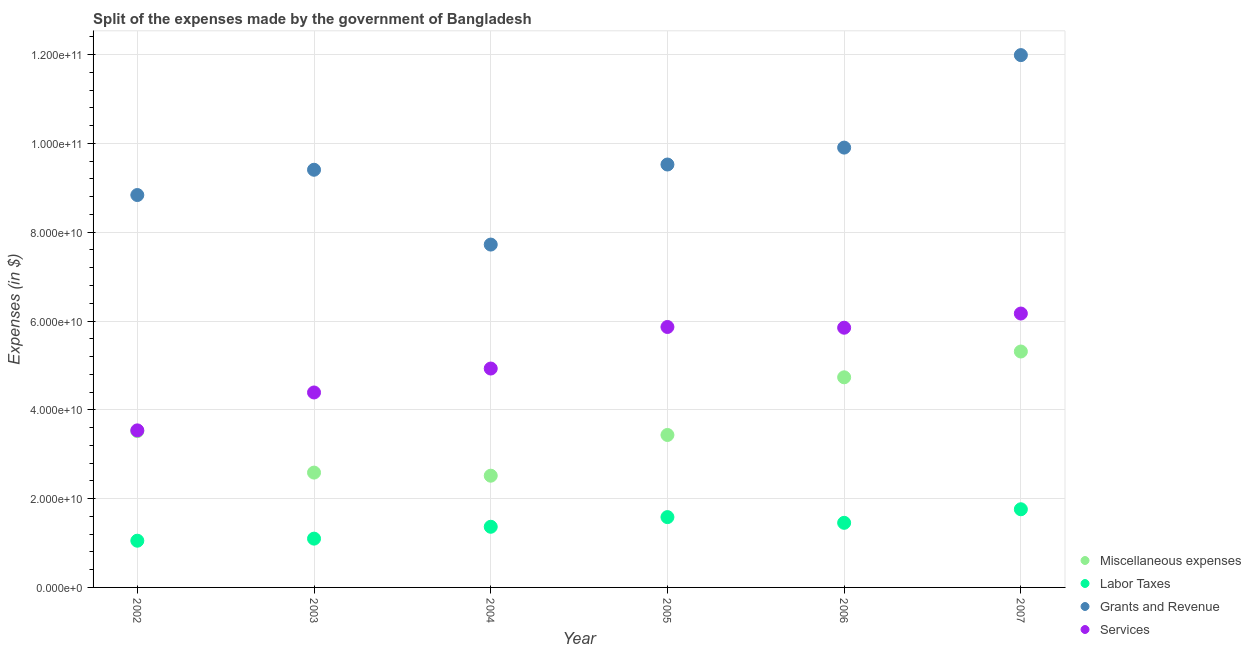Is the number of dotlines equal to the number of legend labels?
Make the answer very short. Yes. What is the amount spent on services in 2004?
Make the answer very short. 4.93e+1. Across all years, what is the maximum amount spent on services?
Your response must be concise. 6.17e+1. Across all years, what is the minimum amount spent on labor taxes?
Offer a terse response. 1.05e+1. What is the total amount spent on grants and revenue in the graph?
Keep it short and to the point. 5.74e+11. What is the difference between the amount spent on miscellaneous expenses in 2003 and that in 2004?
Offer a very short reply. 6.99e+08. What is the difference between the amount spent on labor taxes in 2007 and the amount spent on grants and revenue in 2004?
Provide a short and direct response. -5.96e+1. What is the average amount spent on grants and revenue per year?
Your answer should be compact. 9.56e+1. In the year 2003, what is the difference between the amount spent on labor taxes and amount spent on services?
Make the answer very short. -3.29e+1. In how many years, is the amount spent on grants and revenue greater than 4000000000 $?
Provide a short and direct response. 6. What is the ratio of the amount spent on miscellaneous expenses in 2003 to that in 2007?
Offer a terse response. 0.49. What is the difference between the highest and the second highest amount spent on labor taxes?
Your response must be concise. 1.77e+09. What is the difference between the highest and the lowest amount spent on miscellaneous expenses?
Your answer should be compact. 2.80e+1. In how many years, is the amount spent on labor taxes greater than the average amount spent on labor taxes taken over all years?
Make the answer very short. 3. Is the sum of the amount spent on miscellaneous expenses in 2003 and 2005 greater than the maximum amount spent on grants and revenue across all years?
Ensure brevity in your answer.  No. Is it the case that in every year, the sum of the amount spent on miscellaneous expenses and amount spent on labor taxes is greater than the amount spent on grants and revenue?
Offer a very short reply. No. Is the amount spent on services strictly greater than the amount spent on miscellaneous expenses over the years?
Give a very brief answer. Yes. Is the amount spent on miscellaneous expenses strictly less than the amount spent on services over the years?
Your answer should be compact. Yes. Are the values on the major ticks of Y-axis written in scientific E-notation?
Keep it short and to the point. Yes. Does the graph contain any zero values?
Offer a very short reply. No. How many legend labels are there?
Give a very brief answer. 4. How are the legend labels stacked?
Your answer should be compact. Vertical. What is the title of the graph?
Provide a succinct answer. Split of the expenses made by the government of Bangladesh. Does "United Kingdom" appear as one of the legend labels in the graph?
Offer a terse response. No. What is the label or title of the Y-axis?
Your answer should be very brief. Expenses (in $). What is the Expenses (in $) of Miscellaneous expenses in 2002?
Your response must be concise. 3.52e+1. What is the Expenses (in $) in Labor Taxes in 2002?
Your response must be concise. 1.05e+1. What is the Expenses (in $) of Grants and Revenue in 2002?
Give a very brief answer. 8.84e+1. What is the Expenses (in $) in Services in 2002?
Your answer should be very brief. 3.54e+1. What is the Expenses (in $) of Miscellaneous expenses in 2003?
Your answer should be compact. 2.59e+1. What is the Expenses (in $) of Labor Taxes in 2003?
Make the answer very short. 1.10e+1. What is the Expenses (in $) of Grants and Revenue in 2003?
Offer a very short reply. 9.41e+1. What is the Expenses (in $) in Services in 2003?
Provide a succinct answer. 4.39e+1. What is the Expenses (in $) of Miscellaneous expenses in 2004?
Your answer should be very brief. 2.52e+1. What is the Expenses (in $) of Labor Taxes in 2004?
Provide a succinct answer. 1.37e+1. What is the Expenses (in $) of Grants and Revenue in 2004?
Your answer should be compact. 7.72e+1. What is the Expenses (in $) of Services in 2004?
Your answer should be very brief. 4.93e+1. What is the Expenses (in $) of Miscellaneous expenses in 2005?
Your answer should be very brief. 3.43e+1. What is the Expenses (in $) of Labor Taxes in 2005?
Offer a very short reply. 1.58e+1. What is the Expenses (in $) in Grants and Revenue in 2005?
Your answer should be very brief. 9.52e+1. What is the Expenses (in $) of Services in 2005?
Your response must be concise. 5.87e+1. What is the Expenses (in $) of Miscellaneous expenses in 2006?
Keep it short and to the point. 4.73e+1. What is the Expenses (in $) in Labor Taxes in 2006?
Ensure brevity in your answer.  1.45e+1. What is the Expenses (in $) in Grants and Revenue in 2006?
Make the answer very short. 9.91e+1. What is the Expenses (in $) of Services in 2006?
Give a very brief answer. 5.85e+1. What is the Expenses (in $) in Miscellaneous expenses in 2007?
Your response must be concise. 5.31e+1. What is the Expenses (in $) in Labor Taxes in 2007?
Keep it short and to the point. 1.76e+1. What is the Expenses (in $) in Grants and Revenue in 2007?
Offer a terse response. 1.20e+11. What is the Expenses (in $) of Services in 2007?
Make the answer very short. 6.17e+1. Across all years, what is the maximum Expenses (in $) in Miscellaneous expenses?
Your answer should be very brief. 5.31e+1. Across all years, what is the maximum Expenses (in $) in Labor Taxes?
Ensure brevity in your answer.  1.76e+1. Across all years, what is the maximum Expenses (in $) of Grants and Revenue?
Keep it short and to the point. 1.20e+11. Across all years, what is the maximum Expenses (in $) of Services?
Your answer should be very brief. 6.17e+1. Across all years, what is the minimum Expenses (in $) of Miscellaneous expenses?
Provide a short and direct response. 2.52e+1. Across all years, what is the minimum Expenses (in $) of Labor Taxes?
Offer a terse response. 1.05e+1. Across all years, what is the minimum Expenses (in $) in Grants and Revenue?
Keep it short and to the point. 7.72e+1. Across all years, what is the minimum Expenses (in $) of Services?
Keep it short and to the point. 3.54e+1. What is the total Expenses (in $) in Miscellaneous expenses in the graph?
Offer a terse response. 2.21e+11. What is the total Expenses (in $) of Labor Taxes in the graph?
Provide a short and direct response. 8.32e+1. What is the total Expenses (in $) of Grants and Revenue in the graph?
Provide a short and direct response. 5.74e+11. What is the total Expenses (in $) of Services in the graph?
Give a very brief answer. 3.07e+11. What is the difference between the Expenses (in $) in Miscellaneous expenses in 2002 and that in 2003?
Your answer should be compact. 9.34e+09. What is the difference between the Expenses (in $) in Labor Taxes in 2002 and that in 2003?
Your answer should be very brief. -4.67e+08. What is the difference between the Expenses (in $) in Grants and Revenue in 2002 and that in 2003?
Your answer should be compact. -5.69e+09. What is the difference between the Expenses (in $) in Services in 2002 and that in 2003?
Ensure brevity in your answer.  -8.54e+09. What is the difference between the Expenses (in $) in Miscellaneous expenses in 2002 and that in 2004?
Your answer should be very brief. 1.00e+1. What is the difference between the Expenses (in $) in Labor Taxes in 2002 and that in 2004?
Ensure brevity in your answer.  -3.14e+09. What is the difference between the Expenses (in $) in Grants and Revenue in 2002 and that in 2004?
Provide a short and direct response. 1.12e+1. What is the difference between the Expenses (in $) in Services in 2002 and that in 2004?
Your response must be concise. -1.39e+1. What is the difference between the Expenses (in $) in Miscellaneous expenses in 2002 and that in 2005?
Offer a very short reply. 8.64e+08. What is the difference between the Expenses (in $) in Labor Taxes in 2002 and that in 2005?
Offer a very short reply. -5.32e+09. What is the difference between the Expenses (in $) in Grants and Revenue in 2002 and that in 2005?
Make the answer very short. -6.87e+09. What is the difference between the Expenses (in $) in Services in 2002 and that in 2005?
Ensure brevity in your answer.  -2.33e+1. What is the difference between the Expenses (in $) of Miscellaneous expenses in 2002 and that in 2006?
Your response must be concise. -1.21e+1. What is the difference between the Expenses (in $) of Labor Taxes in 2002 and that in 2006?
Provide a short and direct response. -4.03e+09. What is the difference between the Expenses (in $) of Grants and Revenue in 2002 and that in 2006?
Your answer should be very brief. -1.07e+1. What is the difference between the Expenses (in $) of Services in 2002 and that in 2006?
Keep it short and to the point. -2.31e+1. What is the difference between the Expenses (in $) of Miscellaneous expenses in 2002 and that in 2007?
Your answer should be very brief. -1.79e+1. What is the difference between the Expenses (in $) in Labor Taxes in 2002 and that in 2007?
Your response must be concise. -7.08e+09. What is the difference between the Expenses (in $) of Grants and Revenue in 2002 and that in 2007?
Your answer should be very brief. -3.15e+1. What is the difference between the Expenses (in $) of Services in 2002 and that in 2007?
Make the answer very short. -2.63e+1. What is the difference between the Expenses (in $) in Miscellaneous expenses in 2003 and that in 2004?
Offer a very short reply. 6.99e+08. What is the difference between the Expenses (in $) of Labor Taxes in 2003 and that in 2004?
Your response must be concise. -2.67e+09. What is the difference between the Expenses (in $) of Grants and Revenue in 2003 and that in 2004?
Your answer should be compact. 1.69e+1. What is the difference between the Expenses (in $) in Services in 2003 and that in 2004?
Provide a short and direct response. -5.39e+09. What is the difference between the Expenses (in $) in Miscellaneous expenses in 2003 and that in 2005?
Keep it short and to the point. -8.47e+09. What is the difference between the Expenses (in $) in Labor Taxes in 2003 and that in 2005?
Your answer should be compact. -4.85e+09. What is the difference between the Expenses (in $) in Grants and Revenue in 2003 and that in 2005?
Offer a very short reply. -1.18e+09. What is the difference between the Expenses (in $) of Services in 2003 and that in 2005?
Provide a succinct answer. -1.48e+1. What is the difference between the Expenses (in $) of Miscellaneous expenses in 2003 and that in 2006?
Make the answer very short. -2.15e+1. What is the difference between the Expenses (in $) in Labor Taxes in 2003 and that in 2006?
Keep it short and to the point. -3.56e+09. What is the difference between the Expenses (in $) of Grants and Revenue in 2003 and that in 2006?
Ensure brevity in your answer.  -4.99e+09. What is the difference between the Expenses (in $) in Services in 2003 and that in 2006?
Your answer should be compact. -1.46e+1. What is the difference between the Expenses (in $) of Miscellaneous expenses in 2003 and that in 2007?
Keep it short and to the point. -2.73e+1. What is the difference between the Expenses (in $) of Labor Taxes in 2003 and that in 2007?
Keep it short and to the point. -6.61e+09. What is the difference between the Expenses (in $) in Grants and Revenue in 2003 and that in 2007?
Ensure brevity in your answer.  -2.58e+1. What is the difference between the Expenses (in $) in Services in 2003 and that in 2007?
Your response must be concise. -1.78e+1. What is the difference between the Expenses (in $) of Miscellaneous expenses in 2004 and that in 2005?
Give a very brief answer. -9.17e+09. What is the difference between the Expenses (in $) of Labor Taxes in 2004 and that in 2005?
Ensure brevity in your answer.  -2.18e+09. What is the difference between the Expenses (in $) of Grants and Revenue in 2004 and that in 2005?
Make the answer very short. -1.80e+1. What is the difference between the Expenses (in $) in Services in 2004 and that in 2005?
Give a very brief answer. -9.36e+09. What is the difference between the Expenses (in $) in Miscellaneous expenses in 2004 and that in 2006?
Provide a short and direct response. -2.22e+1. What is the difference between the Expenses (in $) in Labor Taxes in 2004 and that in 2006?
Give a very brief answer. -8.88e+08. What is the difference between the Expenses (in $) in Grants and Revenue in 2004 and that in 2006?
Your response must be concise. -2.18e+1. What is the difference between the Expenses (in $) in Services in 2004 and that in 2006?
Provide a succinct answer. -9.19e+09. What is the difference between the Expenses (in $) of Miscellaneous expenses in 2004 and that in 2007?
Your answer should be compact. -2.80e+1. What is the difference between the Expenses (in $) in Labor Taxes in 2004 and that in 2007?
Offer a terse response. -3.94e+09. What is the difference between the Expenses (in $) of Grants and Revenue in 2004 and that in 2007?
Provide a succinct answer. -4.27e+1. What is the difference between the Expenses (in $) in Services in 2004 and that in 2007?
Provide a succinct answer. -1.24e+1. What is the difference between the Expenses (in $) of Miscellaneous expenses in 2005 and that in 2006?
Offer a very short reply. -1.30e+1. What is the difference between the Expenses (in $) in Labor Taxes in 2005 and that in 2006?
Keep it short and to the point. 1.29e+09. What is the difference between the Expenses (in $) in Grants and Revenue in 2005 and that in 2006?
Your answer should be very brief. -3.81e+09. What is the difference between the Expenses (in $) in Services in 2005 and that in 2006?
Your answer should be very brief. 1.67e+08. What is the difference between the Expenses (in $) of Miscellaneous expenses in 2005 and that in 2007?
Offer a terse response. -1.88e+1. What is the difference between the Expenses (in $) of Labor Taxes in 2005 and that in 2007?
Ensure brevity in your answer.  -1.77e+09. What is the difference between the Expenses (in $) of Grants and Revenue in 2005 and that in 2007?
Your response must be concise. -2.46e+1. What is the difference between the Expenses (in $) of Services in 2005 and that in 2007?
Ensure brevity in your answer.  -3.03e+09. What is the difference between the Expenses (in $) of Miscellaneous expenses in 2006 and that in 2007?
Give a very brief answer. -5.81e+09. What is the difference between the Expenses (in $) in Labor Taxes in 2006 and that in 2007?
Your answer should be very brief. -3.05e+09. What is the difference between the Expenses (in $) of Grants and Revenue in 2006 and that in 2007?
Ensure brevity in your answer.  -2.08e+1. What is the difference between the Expenses (in $) in Services in 2006 and that in 2007?
Offer a terse response. -3.20e+09. What is the difference between the Expenses (in $) of Miscellaneous expenses in 2002 and the Expenses (in $) of Labor Taxes in 2003?
Give a very brief answer. 2.42e+1. What is the difference between the Expenses (in $) in Miscellaneous expenses in 2002 and the Expenses (in $) in Grants and Revenue in 2003?
Your answer should be compact. -5.89e+1. What is the difference between the Expenses (in $) in Miscellaneous expenses in 2002 and the Expenses (in $) in Services in 2003?
Your response must be concise. -8.71e+09. What is the difference between the Expenses (in $) in Labor Taxes in 2002 and the Expenses (in $) in Grants and Revenue in 2003?
Offer a terse response. -8.35e+1. What is the difference between the Expenses (in $) of Labor Taxes in 2002 and the Expenses (in $) of Services in 2003?
Offer a very short reply. -3.34e+1. What is the difference between the Expenses (in $) of Grants and Revenue in 2002 and the Expenses (in $) of Services in 2003?
Offer a very short reply. 4.45e+1. What is the difference between the Expenses (in $) in Miscellaneous expenses in 2002 and the Expenses (in $) in Labor Taxes in 2004?
Your answer should be very brief. 2.15e+1. What is the difference between the Expenses (in $) of Miscellaneous expenses in 2002 and the Expenses (in $) of Grants and Revenue in 2004?
Provide a short and direct response. -4.20e+1. What is the difference between the Expenses (in $) of Miscellaneous expenses in 2002 and the Expenses (in $) of Services in 2004?
Keep it short and to the point. -1.41e+1. What is the difference between the Expenses (in $) of Labor Taxes in 2002 and the Expenses (in $) of Grants and Revenue in 2004?
Your answer should be compact. -6.67e+1. What is the difference between the Expenses (in $) of Labor Taxes in 2002 and the Expenses (in $) of Services in 2004?
Your answer should be compact. -3.88e+1. What is the difference between the Expenses (in $) of Grants and Revenue in 2002 and the Expenses (in $) of Services in 2004?
Ensure brevity in your answer.  3.91e+1. What is the difference between the Expenses (in $) in Miscellaneous expenses in 2002 and the Expenses (in $) in Labor Taxes in 2005?
Ensure brevity in your answer.  1.94e+1. What is the difference between the Expenses (in $) of Miscellaneous expenses in 2002 and the Expenses (in $) of Grants and Revenue in 2005?
Provide a succinct answer. -6.00e+1. What is the difference between the Expenses (in $) in Miscellaneous expenses in 2002 and the Expenses (in $) in Services in 2005?
Provide a succinct answer. -2.35e+1. What is the difference between the Expenses (in $) in Labor Taxes in 2002 and the Expenses (in $) in Grants and Revenue in 2005?
Your answer should be compact. -8.47e+1. What is the difference between the Expenses (in $) in Labor Taxes in 2002 and the Expenses (in $) in Services in 2005?
Provide a short and direct response. -4.81e+1. What is the difference between the Expenses (in $) of Grants and Revenue in 2002 and the Expenses (in $) of Services in 2005?
Your answer should be very brief. 2.97e+1. What is the difference between the Expenses (in $) of Miscellaneous expenses in 2002 and the Expenses (in $) of Labor Taxes in 2006?
Offer a very short reply. 2.07e+1. What is the difference between the Expenses (in $) of Miscellaneous expenses in 2002 and the Expenses (in $) of Grants and Revenue in 2006?
Your answer should be very brief. -6.39e+1. What is the difference between the Expenses (in $) in Miscellaneous expenses in 2002 and the Expenses (in $) in Services in 2006?
Offer a terse response. -2.33e+1. What is the difference between the Expenses (in $) of Labor Taxes in 2002 and the Expenses (in $) of Grants and Revenue in 2006?
Your answer should be compact. -8.85e+1. What is the difference between the Expenses (in $) of Labor Taxes in 2002 and the Expenses (in $) of Services in 2006?
Keep it short and to the point. -4.80e+1. What is the difference between the Expenses (in $) in Grants and Revenue in 2002 and the Expenses (in $) in Services in 2006?
Your answer should be very brief. 2.99e+1. What is the difference between the Expenses (in $) of Miscellaneous expenses in 2002 and the Expenses (in $) of Labor Taxes in 2007?
Provide a succinct answer. 1.76e+1. What is the difference between the Expenses (in $) in Miscellaneous expenses in 2002 and the Expenses (in $) in Grants and Revenue in 2007?
Ensure brevity in your answer.  -8.47e+1. What is the difference between the Expenses (in $) in Miscellaneous expenses in 2002 and the Expenses (in $) in Services in 2007?
Your answer should be compact. -2.65e+1. What is the difference between the Expenses (in $) in Labor Taxes in 2002 and the Expenses (in $) in Grants and Revenue in 2007?
Your response must be concise. -1.09e+11. What is the difference between the Expenses (in $) in Labor Taxes in 2002 and the Expenses (in $) in Services in 2007?
Your answer should be compact. -5.12e+1. What is the difference between the Expenses (in $) of Grants and Revenue in 2002 and the Expenses (in $) of Services in 2007?
Make the answer very short. 2.67e+1. What is the difference between the Expenses (in $) in Miscellaneous expenses in 2003 and the Expenses (in $) in Labor Taxes in 2004?
Provide a short and direct response. 1.22e+1. What is the difference between the Expenses (in $) of Miscellaneous expenses in 2003 and the Expenses (in $) of Grants and Revenue in 2004?
Ensure brevity in your answer.  -5.14e+1. What is the difference between the Expenses (in $) in Miscellaneous expenses in 2003 and the Expenses (in $) in Services in 2004?
Give a very brief answer. -2.34e+1. What is the difference between the Expenses (in $) of Labor Taxes in 2003 and the Expenses (in $) of Grants and Revenue in 2004?
Keep it short and to the point. -6.62e+1. What is the difference between the Expenses (in $) of Labor Taxes in 2003 and the Expenses (in $) of Services in 2004?
Provide a succinct answer. -3.83e+1. What is the difference between the Expenses (in $) of Grants and Revenue in 2003 and the Expenses (in $) of Services in 2004?
Your response must be concise. 4.48e+1. What is the difference between the Expenses (in $) of Miscellaneous expenses in 2003 and the Expenses (in $) of Labor Taxes in 2005?
Provide a short and direct response. 1.00e+1. What is the difference between the Expenses (in $) of Miscellaneous expenses in 2003 and the Expenses (in $) of Grants and Revenue in 2005?
Make the answer very short. -6.94e+1. What is the difference between the Expenses (in $) in Miscellaneous expenses in 2003 and the Expenses (in $) in Services in 2005?
Keep it short and to the point. -3.28e+1. What is the difference between the Expenses (in $) of Labor Taxes in 2003 and the Expenses (in $) of Grants and Revenue in 2005?
Ensure brevity in your answer.  -8.43e+1. What is the difference between the Expenses (in $) of Labor Taxes in 2003 and the Expenses (in $) of Services in 2005?
Offer a very short reply. -4.77e+1. What is the difference between the Expenses (in $) of Grants and Revenue in 2003 and the Expenses (in $) of Services in 2005?
Give a very brief answer. 3.54e+1. What is the difference between the Expenses (in $) of Miscellaneous expenses in 2003 and the Expenses (in $) of Labor Taxes in 2006?
Provide a succinct answer. 1.13e+1. What is the difference between the Expenses (in $) in Miscellaneous expenses in 2003 and the Expenses (in $) in Grants and Revenue in 2006?
Offer a terse response. -7.32e+1. What is the difference between the Expenses (in $) of Miscellaneous expenses in 2003 and the Expenses (in $) of Services in 2006?
Your response must be concise. -3.26e+1. What is the difference between the Expenses (in $) in Labor Taxes in 2003 and the Expenses (in $) in Grants and Revenue in 2006?
Keep it short and to the point. -8.81e+1. What is the difference between the Expenses (in $) in Labor Taxes in 2003 and the Expenses (in $) in Services in 2006?
Keep it short and to the point. -4.75e+1. What is the difference between the Expenses (in $) of Grants and Revenue in 2003 and the Expenses (in $) of Services in 2006?
Ensure brevity in your answer.  3.56e+1. What is the difference between the Expenses (in $) in Miscellaneous expenses in 2003 and the Expenses (in $) in Labor Taxes in 2007?
Your answer should be compact. 8.26e+09. What is the difference between the Expenses (in $) in Miscellaneous expenses in 2003 and the Expenses (in $) in Grants and Revenue in 2007?
Ensure brevity in your answer.  -9.40e+1. What is the difference between the Expenses (in $) in Miscellaneous expenses in 2003 and the Expenses (in $) in Services in 2007?
Provide a short and direct response. -3.58e+1. What is the difference between the Expenses (in $) in Labor Taxes in 2003 and the Expenses (in $) in Grants and Revenue in 2007?
Your response must be concise. -1.09e+11. What is the difference between the Expenses (in $) in Labor Taxes in 2003 and the Expenses (in $) in Services in 2007?
Offer a very short reply. -5.07e+1. What is the difference between the Expenses (in $) in Grants and Revenue in 2003 and the Expenses (in $) in Services in 2007?
Ensure brevity in your answer.  3.24e+1. What is the difference between the Expenses (in $) of Miscellaneous expenses in 2004 and the Expenses (in $) of Labor Taxes in 2005?
Ensure brevity in your answer.  9.33e+09. What is the difference between the Expenses (in $) in Miscellaneous expenses in 2004 and the Expenses (in $) in Grants and Revenue in 2005?
Provide a succinct answer. -7.01e+1. What is the difference between the Expenses (in $) in Miscellaneous expenses in 2004 and the Expenses (in $) in Services in 2005?
Ensure brevity in your answer.  -3.35e+1. What is the difference between the Expenses (in $) in Labor Taxes in 2004 and the Expenses (in $) in Grants and Revenue in 2005?
Your answer should be very brief. -8.16e+1. What is the difference between the Expenses (in $) in Labor Taxes in 2004 and the Expenses (in $) in Services in 2005?
Offer a very short reply. -4.50e+1. What is the difference between the Expenses (in $) in Grants and Revenue in 2004 and the Expenses (in $) in Services in 2005?
Ensure brevity in your answer.  1.86e+1. What is the difference between the Expenses (in $) of Miscellaneous expenses in 2004 and the Expenses (in $) of Labor Taxes in 2006?
Make the answer very short. 1.06e+1. What is the difference between the Expenses (in $) of Miscellaneous expenses in 2004 and the Expenses (in $) of Grants and Revenue in 2006?
Provide a succinct answer. -7.39e+1. What is the difference between the Expenses (in $) of Miscellaneous expenses in 2004 and the Expenses (in $) of Services in 2006?
Ensure brevity in your answer.  -3.33e+1. What is the difference between the Expenses (in $) of Labor Taxes in 2004 and the Expenses (in $) of Grants and Revenue in 2006?
Provide a succinct answer. -8.54e+1. What is the difference between the Expenses (in $) in Labor Taxes in 2004 and the Expenses (in $) in Services in 2006?
Keep it short and to the point. -4.48e+1. What is the difference between the Expenses (in $) of Grants and Revenue in 2004 and the Expenses (in $) of Services in 2006?
Keep it short and to the point. 1.87e+1. What is the difference between the Expenses (in $) of Miscellaneous expenses in 2004 and the Expenses (in $) of Labor Taxes in 2007?
Offer a terse response. 7.56e+09. What is the difference between the Expenses (in $) in Miscellaneous expenses in 2004 and the Expenses (in $) in Grants and Revenue in 2007?
Ensure brevity in your answer.  -9.47e+1. What is the difference between the Expenses (in $) of Miscellaneous expenses in 2004 and the Expenses (in $) of Services in 2007?
Provide a short and direct response. -3.65e+1. What is the difference between the Expenses (in $) in Labor Taxes in 2004 and the Expenses (in $) in Grants and Revenue in 2007?
Your answer should be very brief. -1.06e+11. What is the difference between the Expenses (in $) in Labor Taxes in 2004 and the Expenses (in $) in Services in 2007?
Give a very brief answer. -4.80e+1. What is the difference between the Expenses (in $) in Grants and Revenue in 2004 and the Expenses (in $) in Services in 2007?
Ensure brevity in your answer.  1.55e+1. What is the difference between the Expenses (in $) of Miscellaneous expenses in 2005 and the Expenses (in $) of Labor Taxes in 2006?
Make the answer very short. 1.98e+1. What is the difference between the Expenses (in $) in Miscellaneous expenses in 2005 and the Expenses (in $) in Grants and Revenue in 2006?
Your response must be concise. -6.47e+1. What is the difference between the Expenses (in $) in Miscellaneous expenses in 2005 and the Expenses (in $) in Services in 2006?
Your answer should be compact. -2.42e+1. What is the difference between the Expenses (in $) of Labor Taxes in 2005 and the Expenses (in $) of Grants and Revenue in 2006?
Give a very brief answer. -8.32e+1. What is the difference between the Expenses (in $) of Labor Taxes in 2005 and the Expenses (in $) of Services in 2006?
Give a very brief answer. -4.27e+1. What is the difference between the Expenses (in $) in Grants and Revenue in 2005 and the Expenses (in $) in Services in 2006?
Offer a terse response. 3.68e+1. What is the difference between the Expenses (in $) of Miscellaneous expenses in 2005 and the Expenses (in $) of Labor Taxes in 2007?
Ensure brevity in your answer.  1.67e+1. What is the difference between the Expenses (in $) of Miscellaneous expenses in 2005 and the Expenses (in $) of Grants and Revenue in 2007?
Provide a short and direct response. -8.56e+1. What is the difference between the Expenses (in $) of Miscellaneous expenses in 2005 and the Expenses (in $) of Services in 2007?
Ensure brevity in your answer.  -2.74e+1. What is the difference between the Expenses (in $) of Labor Taxes in 2005 and the Expenses (in $) of Grants and Revenue in 2007?
Make the answer very short. -1.04e+11. What is the difference between the Expenses (in $) in Labor Taxes in 2005 and the Expenses (in $) in Services in 2007?
Your response must be concise. -4.58e+1. What is the difference between the Expenses (in $) in Grants and Revenue in 2005 and the Expenses (in $) in Services in 2007?
Give a very brief answer. 3.36e+1. What is the difference between the Expenses (in $) of Miscellaneous expenses in 2006 and the Expenses (in $) of Labor Taxes in 2007?
Provide a succinct answer. 2.97e+1. What is the difference between the Expenses (in $) in Miscellaneous expenses in 2006 and the Expenses (in $) in Grants and Revenue in 2007?
Give a very brief answer. -7.26e+1. What is the difference between the Expenses (in $) of Miscellaneous expenses in 2006 and the Expenses (in $) of Services in 2007?
Offer a terse response. -1.44e+1. What is the difference between the Expenses (in $) of Labor Taxes in 2006 and the Expenses (in $) of Grants and Revenue in 2007?
Provide a succinct answer. -1.05e+11. What is the difference between the Expenses (in $) in Labor Taxes in 2006 and the Expenses (in $) in Services in 2007?
Your response must be concise. -4.71e+1. What is the difference between the Expenses (in $) in Grants and Revenue in 2006 and the Expenses (in $) in Services in 2007?
Your response must be concise. 3.74e+1. What is the average Expenses (in $) of Miscellaneous expenses per year?
Give a very brief answer. 3.68e+1. What is the average Expenses (in $) in Labor Taxes per year?
Your response must be concise. 1.39e+1. What is the average Expenses (in $) of Grants and Revenue per year?
Ensure brevity in your answer.  9.56e+1. What is the average Expenses (in $) in Services per year?
Ensure brevity in your answer.  5.12e+1. In the year 2002, what is the difference between the Expenses (in $) of Miscellaneous expenses and Expenses (in $) of Labor Taxes?
Your response must be concise. 2.47e+1. In the year 2002, what is the difference between the Expenses (in $) in Miscellaneous expenses and Expenses (in $) in Grants and Revenue?
Offer a terse response. -5.32e+1. In the year 2002, what is the difference between the Expenses (in $) of Miscellaneous expenses and Expenses (in $) of Services?
Provide a succinct answer. -1.71e+08. In the year 2002, what is the difference between the Expenses (in $) of Labor Taxes and Expenses (in $) of Grants and Revenue?
Your response must be concise. -7.79e+1. In the year 2002, what is the difference between the Expenses (in $) in Labor Taxes and Expenses (in $) in Services?
Keep it short and to the point. -2.48e+1. In the year 2002, what is the difference between the Expenses (in $) of Grants and Revenue and Expenses (in $) of Services?
Ensure brevity in your answer.  5.30e+1. In the year 2003, what is the difference between the Expenses (in $) of Miscellaneous expenses and Expenses (in $) of Labor Taxes?
Ensure brevity in your answer.  1.49e+1. In the year 2003, what is the difference between the Expenses (in $) of Miscellaneous expenses and Expenses (in $) of Grants and Revenue?
Provide a succinct answer. -6.82e+1. In the year 2003, what is the difference between the Expenses (in $) of Miscellaneous expenses and Expenses (in $) of Services?
Offer a terse response. -1.80e+1. In the year 2003, what is the difference between the Expenses (in $) of Labor Taxes and Expenses (in $) of Grants and Revenue?
Keep it short and to the point. -8.31e+1. In the year 2003, what is the difference between the Expenses (in $) in Labor Taxes and Expenses (in $) in Services?
Keep it short and to the point. -3.29e+1. In the year 2003, what is the difference between the Expenses (in $) in Grants and Revenue and Expenses (in $) in Services?
Offer a terse response. 5.02e+1. In the year 2004, what is the difference between the Expenses (in $) in Miscellaneous expenses and Expenses (in $) in Labor Taxes?
Your response must be concise. 1.15e+1. In the year 2004, what is the difference between the Expenses (in $) of Miscellaneous expenses and Expenses (in $) of Grants and Revenue?
Offer a very short reply. -5.21e+1. In the year 2004, what is the difference between the Expenses (in $) in Miscellaneous expenses and Expenses (in $) in Services?
Provide a succinct answer. -2.41e+1. In the year 2004, what is the difference between the Expenses (in $) in Labor Taxes and Expenses (in $) in Grants and Revenue?
Make the answer very short. -6.36e+1. In the year 2004, what is the difference between the Expenses (in $) of Labor Taxes and Expenses (in $) of Services?
Provide a succinct answer. -3.56e+1. In the year 2004, what is the difference between the Expenses (in $) in Grants and Revenue and Expenses (in $) in Services?
Your answer should be very brief. 2.79e+1. In the year 2005, what is the difference between the Expenses (in $) in Miscellaneous expenses and Expenses (in $) in Labor Taxes?
Your answer should be compact. 1.85e+1. In the year 2005, what is the difference between the Expenses (in $) in Miscellaneous expenses and Expenses (in $) in Grants and Revenue?
Your answer should be very brief. -6.09e+1. In the year 2005, what is the difference between the Expenses (in $) in Miscellaneous expenses and Expenses (in $) in Services?
Your response must be concise. -2.43e+1. In the year 2005, what is the difference between the Expenses (in $) of Labor Taxes and Expenses (in $) of Grants and Revenue?
Your response must be concise. -7.94e+1. In the year 2005, what is the difference between the Expenses (in $) in Labor Taxes and Expenses (in $) in Services?
Offer a very short reply. -4.28e+1. In the year 2005, what is the difference between the Expenses (in $) in Grants and Revenue and Expenses (in $) in Services?
Offer a very short reply. 3.66e+1. In the year 2006, what is the difference between the Expenses (in $) in Miscellaneous expenses and Expenses (in $) in Labor Taxes?
Your answer should be compact. 3.28e+1. In the year 2006, what is the difference between the Expenses (in $) of Miscellaneous expenses and Expenses (in $) of Grants and Revenue?
Keep it short and to the point. -5.17e+1. In the year 2006, what is the difference between the Expenses (in $) of Miscellaneous expenses and Expenses (in $) of Services?
Ensure brevity in your answer.  -1.12e+1. In the year 2006, what is the difference between the Expenses (in $) in Labor Taxes and Expenses (in $) in Grants and Revenue?
Your response must be concise. -8.45e+1. In the year 2006, what is the difference between the Expenses (in $) in Labor Taxes and Expenses (in $) in Services?
Ensure brevity in your answer.  -4.39e+1. In the year 2006, what is the difference between the Expenses (in $) of Grants and Revenue and Expenses (in $) of Services?
Offer a terse response. 4.06e+1. In the year 2007, what is the difference between the Expenses (in $) of Miscellaneous expenses and Expenses (in $) of Labor Taxes?
Give a very brief answer. 3.55e+1. In the year 2007, what is the difference between the Expenses (in $) of Miscellaneous expenses and Expenses (in $) of Grants and Revenue?
Your response must be concise. -6.68e+1. In the year 2007, what is the difference between the Expenses (in $) in Miscellaneous expenses and Expenses (in $) in Services?
Make the answer very short. -8.55e+09. In the year 2007, what is the difference between the Expenses (in $) in Labor Taxes and Expenses (in $) in Grants and Revenue?
Make the answer very short. -1.02e+11. In the year 2007, what is the difference between the Expenses (in $) in Labor Taxes and Expenses (in $) in Services?
Your answer should be very brief. -4.41e+1. In the year 2007, what is the difference between the Expenses (in $) in Grants and Revenue and Expenses (in $) in Services?
Your response must be concise. 5.82e+1. What is the ratio of the Expenses (in $) in Miscellaneous expenses in 2002 to that in 2003?
Your answer should be very brief. 1.36. What is the ratio of the Expenses (in $) in Labor Taxes in 2002 to that in 2003?
Offer a very short reply. 0.96. What is the ratio of the Expenses (in $) in Grants and Revenue in 2002 to that in 2003?
Your response must be concise. 0.94. What is the ratio of the Expenses (in $) of Services in 2002 to that in 2003?
Your answer should be compact. 0.81. What is the ratio of the Expenses (in $) of Miscellaneous expenses in 2002 to that in 2004?
Your response must be concise. 1.4. What is the ratio of the Expenses (in $) of Labor Taxes in 2002 to that in 2004?
Offer a very short reply. 0.77. What is the ratio of the Expenses (in $) of Grants and Revenue in 2002 to that in 2004?
Your answer should be compact. 1.14. What is the ratio of the Expenses (in $) of Services in 2002 to that in 2004?
Your answer should be compact. 0.72. What is the ratio of the Expenses (in $) in Miscellaneous expenses in 2002 to that in 2005?
Offer a terse response. 1.03. What is the ratio of the Expenses (in $) of Labor Taxes in 2002 to that in 2005?
Provide a succinct answer. 0.66. What is the ratio of the Expenses (in $) of Grants and Revenue in 2002 to that in 2005?
Ensure brevity in your answer.  0.93. What is the ratio of the Expenses (in $) of Services in 2002 to that in 2005?
Offer a very short reply. 0.6. What is the ratio of the Expenses (in $) in Miscellaneous expenses in 2002 to that in 2006?
Ensure brevity in your answer.  0.74. What is the ratio of the Expenses (in $) in Labor Taxes in 2002 to that in 2006?
Ensure brevity in your answer.  0.72. What is the ratio of the Expenses (in $) in Grants and Revenue in 2002 to that in 2006?
Provide a succinct answer. 0.89. What is the ratio of the Expenses (in $) in Services in 2002 to that in 2006?
Your response must be concise. 0.6. What is the ratio of the Expenses (in $) in Miscellaneous expenses in 2002 to that in 2007?
Ensure brevity in your answer.  0.66. What is the ratio of the Expenses (in $) in Labor Taxes in 2002 to that in 2007?
Your answer should be compact. 0.6. What is the ratio of the Expenses (in $) of Grants and Revenue in 2002 to that in 2007?
Offer a terse response. 0.74. What is the ratio of the Expenses (in $) in Services in 2002 to that in 2007?
Ensure brevity in your answer.  0.57. What is the ratio of the Expenses (in $) of Miscellaneous expenses in 2003 to that in 2004?
Provide a succinct answer. 1.03. What is the ratio of the Expenses (in $) of Labor Taxes in 2003 to that in 2004?
Ensure brevity in your answer.  0.8. What is the ratio of the Expenses (in $) of Grants and Revenue in 2003 to that in 2004?
Provide a short and direct response. 1.22. What is the ratio of the Expenses (in $) in Services in 2003 to that in 2004?
Offer a terse response. 0.89. What is the ratio of the Expenses (in $) in Miscellaneous expenses in 2003 to that in 2005?
Your response must be concise. 0.75. What is the ratio of the Expenses (in $) of Labor Taxes in 2003 to that in 2005?
Make the answer very short. 0.69. What is the ratio of the Expenses (in $) of Grants and Revenue in 2003 to that in 2005?
Your answer should be very brief. 0.99. What is the ratio of the Expenses (in $) of Services in 2003 to that in 2005?
Give a very brief answer. 0.75. What is the ratio of the Expenses (in $) in Miscellaneous expenses in 2003 to that in 2006?
Your answer should be compact. 0.55. What is the ratio of the Expenses (in $) of Labor Taxes in 2003 to that in 2006?
Make the answer very short. 0.76. What is the ratio of the Expenses (in $) in Grants and Revenue in 2003 to that in 2006?
Keep it short and to the point. 0.95. What is the ratio of the Expenses (in $) of Services in 2003 to that in 2006?
Offer a very short reply. 0.75. What is the ratio of the Expenses (in $) of Miscellaneous expenses in 2003 to that in 2007?
Ensure brevity in your answer.  0.49. What is the ratio of the Expenses (in $) in Labor Taxes in 2003 to that in 2007?
Provide a succinct answer. 0.62. What is the ratio of the Expenses (in $) in Grants and Revenue in 2003 to that in 2007?
Give a very brief answer. 0.78. What is the ratio of the Expenses (in $) of Services in 2003 to that in 2007?
Your answer should be compact. 0.71. What is the ratio of the Expenses (in $) of Miscellaneous expenses in 2004 to that in 2005?
Your answer should be compact. 0.73. What is the ratio of the Expenses (in $) of Labor Taxes in 2004 to that in 2005?
Offer a very short reply. 0.86. What is the ratio of the Expenses (in $) in Grants and Revenue in 2004 to that in 2005?
Provide a short and direct response. 0.81. What is the ratio of the Expenses (in $) in Services in 2004 to that in 2005?
Your answer should be compact. 0.84. What is the ratio of the Expenses (in $) of Miscellaneous expenses in 2004 to that in 2006?
Keep it short and to the point. 0.53. What is the ratio of the Expenses (in $) of Labor Taxes in 2004 to that in 2006?
Provide a succinct answer. 0.94. What is the ratio of the Expenses (in $) in Grants and Revenue in 2004 to that in 2006?
Your response must be concise. 0.78. What is the ratio of the Expenses (in $) in Services in 2004 to that in 2006?
Your answer should be very brief. 0.84. What is the ratio of the Expenses (in $) of Miscellaneous expenses in 2004 to that in 2007?
Provide a short and direct response. 0.47. What is the ratio of the Expenses (in $) in Labor Taxes in 2004 to that in 2007?
Your response must be concise. 0.78. What is the ratio of the Expenses (in $) in Grants and Revenue in 2004 to that in 2007?
Keep it short and to the point. 0.64. What is the ratio of the Expenses (in $) of Services in 2004 to that in 2007?
Make the answer very short. 0.8. What is the ratio of the Expenses (in $) of Miscellaneous expenses in 2005 to that in 2006?
Provide a short and direct response. 0.73. What is the ratio of the Expenses (in $) of Labor Taxes in 2005 to that in 2006?
Ensure brevity in your answer.  1.09. What is the ratio of the Expenses (in $) in Grants and Revenue in 2005 to that in 2006?
Make the answer very short. 0.96. What is the ratio of the Expenses (in $) in Miscellaneous expenses in 2005 to that in 2007?
Provide a succinct answer. 0.65. What is the ratio of the Expenses (in $) in Labor Taxes in 2005 to that in 2007?
Provide a short and direct response. 0.9. What is the ratio of the Expenses (in $) of Grants and Revenue in 2005 to that in 2007?
Ensure brevity in your answer.  0.79. What is the ratio of the Expenses (in $) of Services in 2005 to that in 2007?
Provide a succinct answer. 0.95. What is the ratio of the Expenses (in $) of Miscellaneous expenses in 2006 to that in 2007?
Your response must be concise. 0.89. What is the ratio of the Expenses (in $) of Labor Taxes in 2006 to that in 2007?
Ensure brevity in your answer.  0.83. What is the ratio of the Expenses (in $) in Grants and Revenue in 2006 to that in 2007?
Provide a succinct answer. 0.83. What is the ratio of the Expenses (in $) in Services in 2006 to that in 2007?
Give a very brief answer. 0.95. What is the difference between the highest and the second highest Expenses (in $) of Miscellaneous expenses?
Provide a short and direct response. 5.81e+09. What is the difference between the highest and the second highest Expenses (in $) in Labor Taxes?
Offer a terse response. 1.77e+09. What is the difference between the highest and the second highest Expenses (in $) in Grants and Revenue?
Your answer should be very brief. 2.08e+1. What is the difference between the highest and the second highest Expenses (in $) in Services?
Ensure brevity in your answer.  3.03e+09. What is the difference between the highest and the lowest Expenses (in $) in Miscellaneous expenses?
Ensure brevity in your answer.  2.80e+1. What is the difference between the highest and the lowest Expenses (in $) of Labor Taxes?
Your answer should be compact. 7.08e+09. What is the difference between the highest and the lowest Expenses (in $) of Grants and Revenue?
Ensure brevity in your answer.  4.27e+1. What is the difference between the highest and the lowest Expenses (in $) in Services?
Keep it short and to the point. 2.63e+1. 